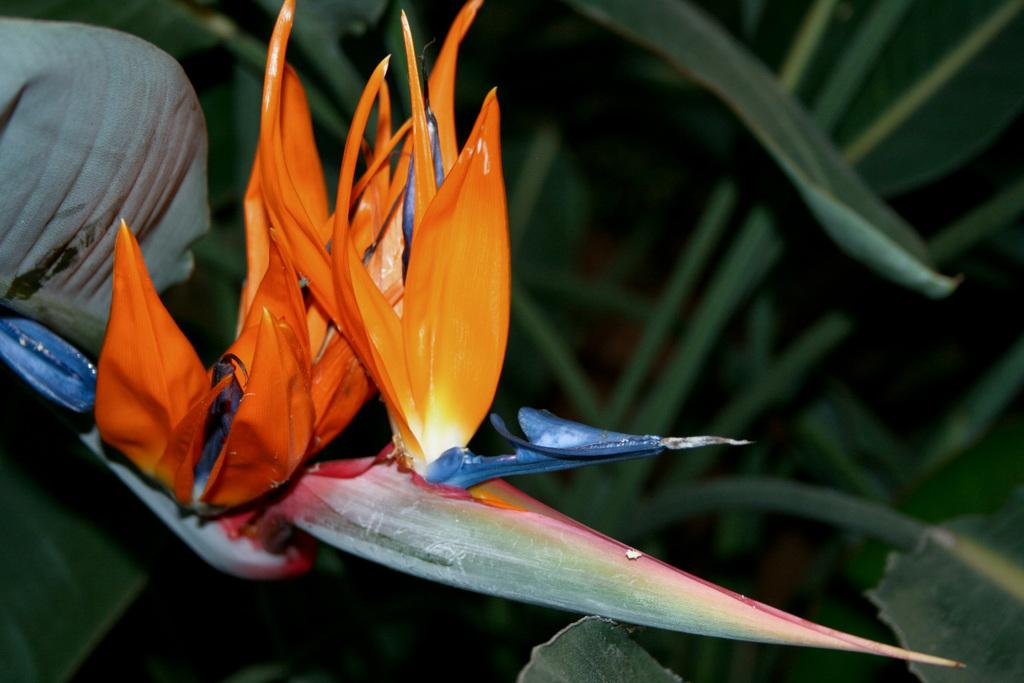How many flowers are on the plant in the image? There are two flowers on the plant in the image. What colors are the flowers? One flower is orange in color, and the other flower is violet in color. Are there any other plants visible in the image? Yes, there are plants visible at the back of the image. What is the opinion of the orange flower about the violet flower in the image? There is no indication in the image that the flowers have opinions, as they are inanimate objects. 